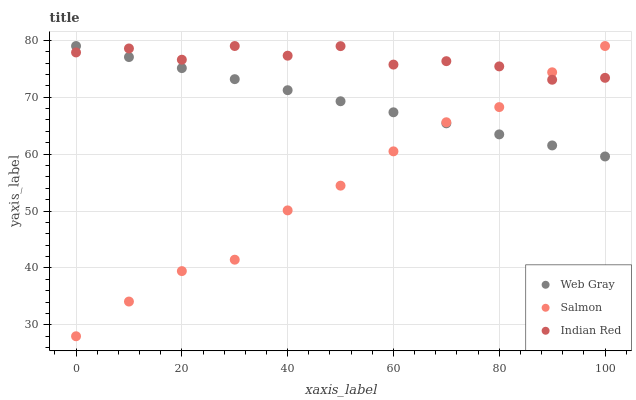Does Salmon have the minimum area under the curve?
Answer yes or no. Yes. Does Indian Red have the maximum area under the curve?
Answer yes or no. Yes. Does Indian Red have the minimum area under the curve?
Answer yes or no. No. Does Salmon have the maximum area under the curve?
Answer yes or no. No. Is Web Gray the smoothest?
Answer yes or no. Yes. Is Indian Red the roughest?
Answer yes or no. Yes. Is Salmon the smoothest?
Answer yes or no. No. Is Salmon the roughest?
Answer yes or no. No. Does Salmon have the lowest value?
Answer yes or no. Yes. Does Indian Red have the lowest value?
Answer yes or no. No. Does Indian Red have the highest value?
Answer yes or no. Yes. Does Indian Red intersect Salmon?
Answer yes or no. Yes. Is Indian Red less than Salmon?
Answer yes or no. No. Is Indian Red greater than Salmon?
Answer yes or no. No. 